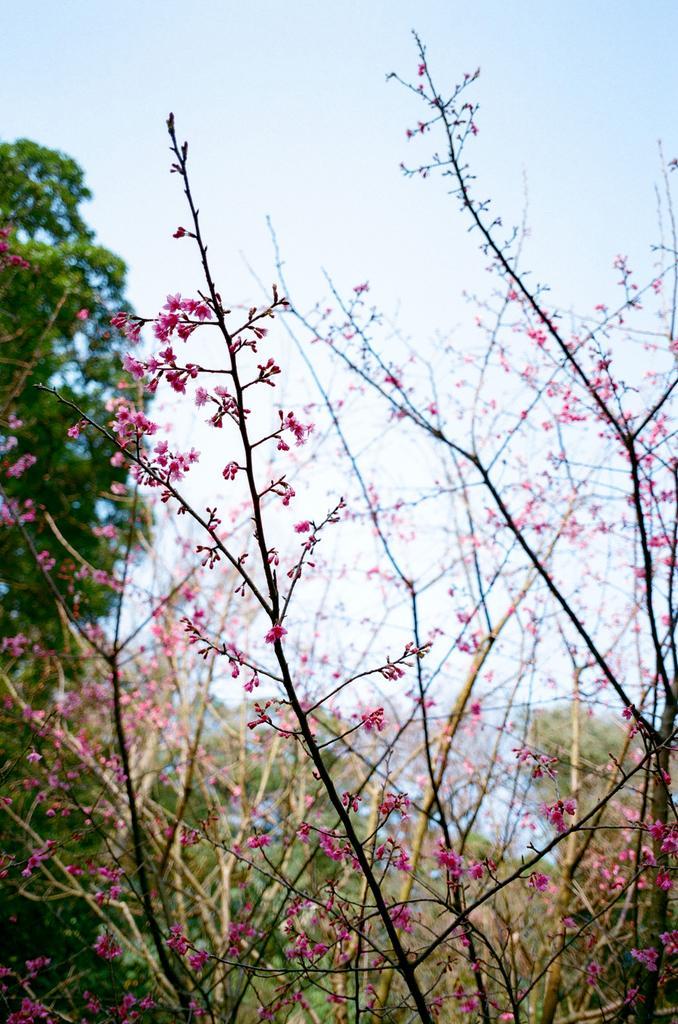Describe this image in one or two sentences. In this image there are flowers on the dry branches of a plant, behind the plant there are trees. 